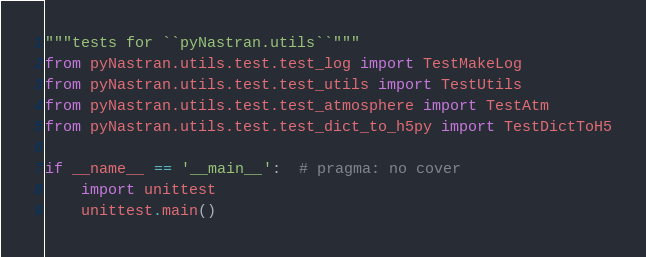Convert code to text. <code><loc_0><loc_0><loc_500><loc_500><_Python_>"""tests for ``pyNastran.utils``"""
from pyNastran.utils.test.test_log import TestMakeLog
from pyNastran.utils.test.test_utils import TestUtils
from pyNastran.utils.test.test_atmosphere import TestAtm
from pyNastran.utils.test.test_dict_to_h5py import TestDictToH5

if __name__ == '__main__':  # pragma: no cover
    import unittest
    unittest.main()
</code> 